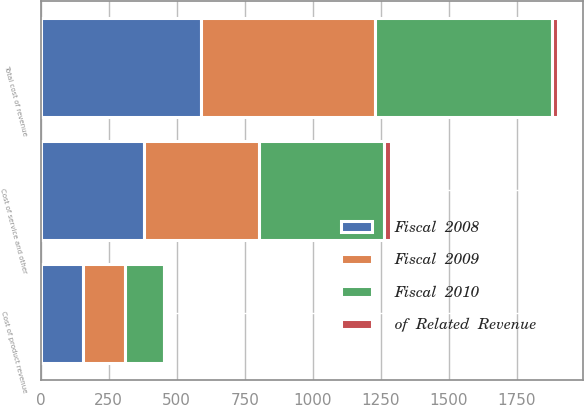Convert chart. <chart><loc_0><loc_0><loc_500><loc_500><stacked_bar_chart><ecel><fcel>Cost of product revenue<fcel>Cost of service and other<fcel>Total cost of revenue<nl><fcel>Fiscal  2010<fcel>144<fcel>460<fcel>653<nl><fcel>of  Related  Revenue<fcel>10<fcel>23<fcel>19<nl><fcel>Fiscal  2009<fcel>156<fcel>422<fcel>637<nl><fcel>Fiscal  2008<fcel>154<fcel>381<fcel>590<nl></chart> 